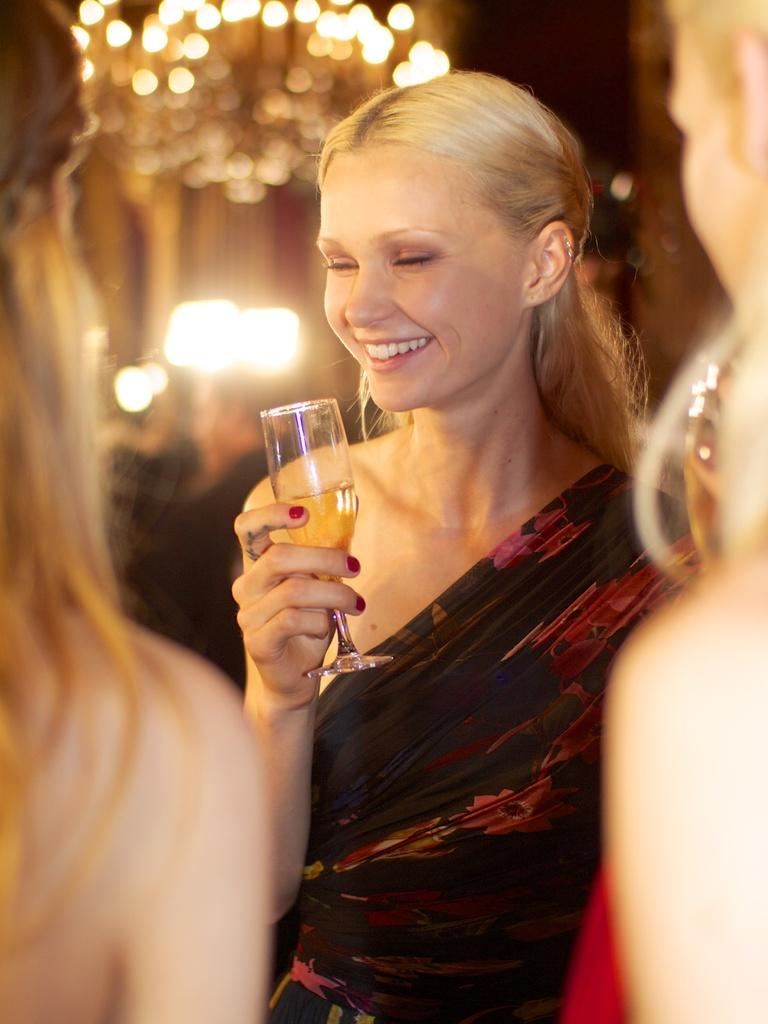How many women are in the image? There are three women in the image. Can you describe the clothing of one of the women? One of the women is wearing a red dress. What is the woman in the red dress holding in her hand? The woman in the red dress is holding a glass in her hand. Are there any dinosaurs visible in the image? No, there are no dinosaurs present in the image. 